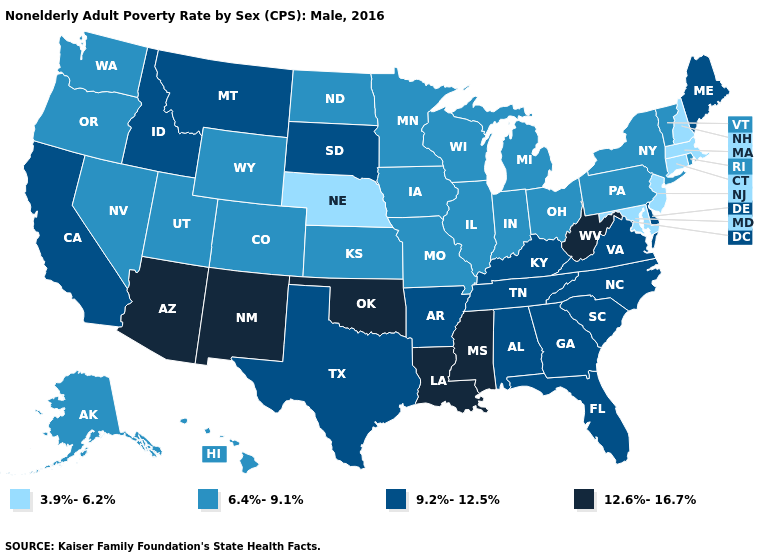Does the first symbol in the legend represent the smallest category?
Answer briefly. Yes. Among the states that border Massachusetts , does New Hampshire have the lowest value?
Give a very brief answer. Yes. Does Arizona have the lowest value in the West?
Keep it brief. No. Does Wyoming have a higher value than Maryland?
Answer briefly. Yes. What is the value of Oklahoma?
Give a very brief answer. 12.6%-16.7%. Does Nebraska have the lowest value in the USA?
Give a very brief answer. Yes. What is the highest value in states that border New Mexico?
Keep it brief. 12.6%-16.7%. Name the states that have a value in the range 9.2%-12.5%?
Keep it brief. Alabama, Arkansas, California, Delaware, Florida, Georgia, Idaho, Kentucky, Maine, Montana, North Carolina, South Carolina, South Dakota, Tennessee, Texas, Virginia. Among the states that border Tennessee , does Mississippi have the highest value?
Be succinct. Yes. Among the states that border Washington , which have the highest value?
Keep it brief. Idaho. Name the states that have a value in the range 6.4%-9.1%?
Quick response, please. Alaska, Colorado, Hawaii, Illinois, Indiana, Iowa, Kansas, Michigan, Minnesota, Missouri, Nevada, New York, North Dakota, Ohio, Oregon, Pennsylvania, Rhode Island, Utah, Vermont, Washington, Wisconsin, Wyoming. Does the map have missing data?
Be succinct. No. Name the states that have a value in the range 9.2%-12.5%?
Be succinct. Alabama, Arkansas, California, Delaware, Florida, Georgia, Idaho, Kentucky, Maine, Montana, North Carolina, South Carolina, South Dakota, Tennessee, Texas, Virginia. Which states have the lowest value in the USA?
Be succinct. Connecticut, Maryland, Massachusetts, Nebraska, New Hampshire, New Jersey. 